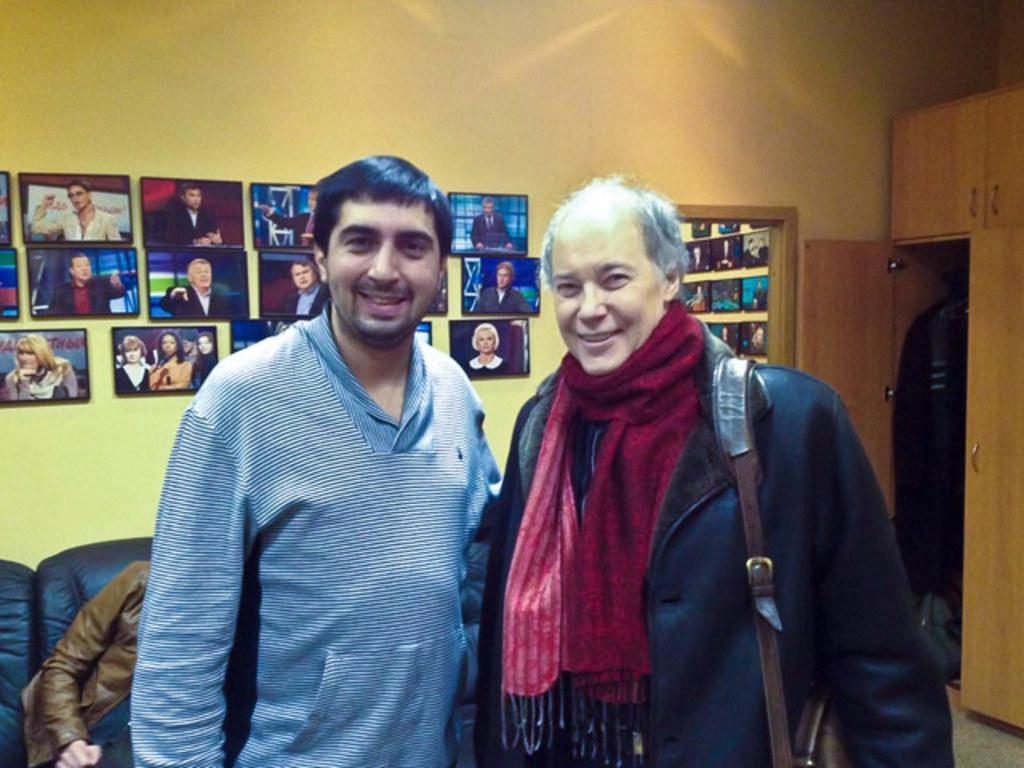Please provide a concise description of this image. In this picture there are two men in the center of the image and there is another person on the sofa in the bottom left side of the image and there are photographs on the wall and there are cupboards in the background area of the image. 